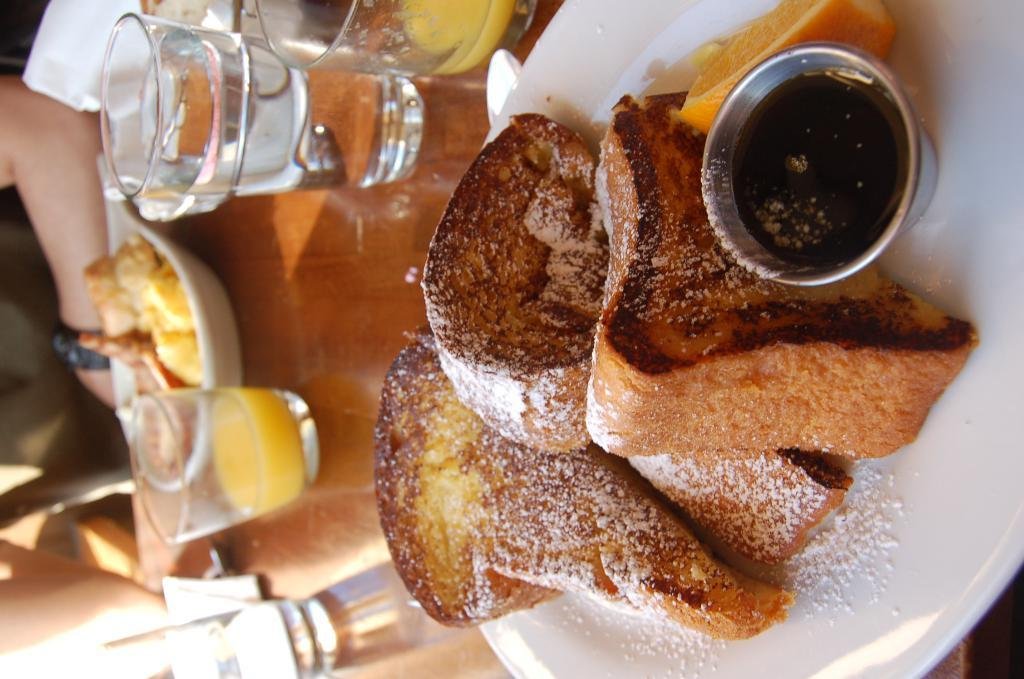What is the main food item in the image? There is a food item in a plate in the center of the image. What other tableware can be seen in the image? There are glasses and bowls on the table. Is there anyone present in the image? Yes, there is a person to the left side of the image. What type of carpenter tools can be seen on the table in the image? There are no carpenter tools present in the image. Is there any dirt or blood visible on the food item in the image? There is no dirt or blood visible on the food item in the image. 